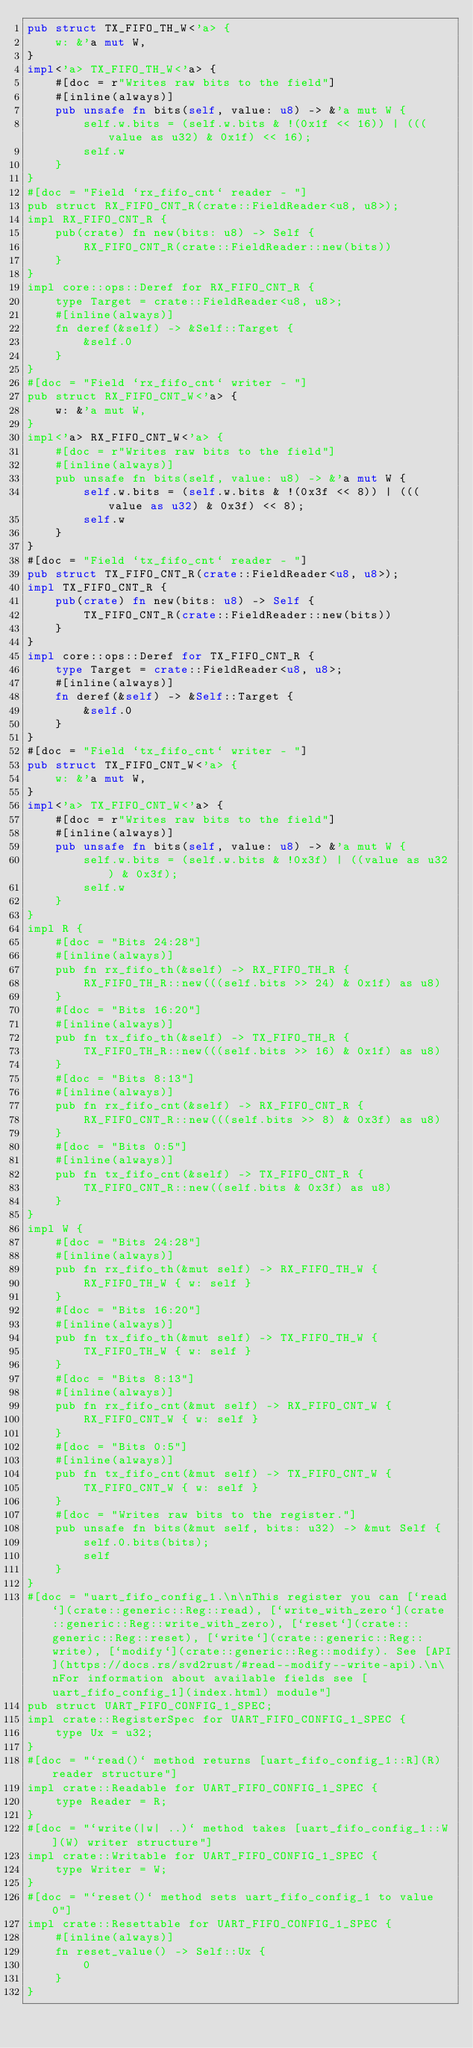Convert code to text. <code><loc_0><loc_0><loc_500><loc_500><_Rust_>pub struct TX_FIFO_TH_W<'a> {
    w: &'a mut W,
}
impl<'a> TX_FIFO_TH_W<'a> {
    #[doc = r"Writes raw bits to the field"]
    #[inline(always)]
    pub unsafe fn bits(self, value: u8) -> &'a mut W {
        self.w.bits = (self.w.bits & !(0x1f << 16)) | (((value as u32) & 0x1f) << 16);
        self.w
    }
}
#[doc = "Field `rx_fifo_cnt` reader - "]
pub struct RX_FIFO_CNT_R(crate::FieldReader<u8, u8>);
impl RX_FIFO_CNT_R {
    pub(crate) fn new(bits: u8) -> Self {
        RX_FIFO_CNT_R(crate::FieldReader::new(bits))
    }
}
impl core::ops::Deref for RX_FIFO_CNT_R {
    type Target = crate::FieldReader<u8, u8>;
    #[inline(always)]
    fn deref(&self) -> &Self::Target {
        &self.0
    }
}
#[doc = "Field `rx_fifo_cnt` writer - "]
pub struct RX_FIFO_CNT_W<'a> {
    w: &'a mut W,
}
impl<'a> RX_FIFO_CNT_W<'a> {
    #[doc = r"Writes raw bits to the field"]
    #[inline(always)]
    pub unsafe fn bits(self, value: u8) -> &'a mut W {
        self.w.bits = (self.w.bits & !(0x3f << 8)) | (((value as u32) & 0x3f) << 8);
        self.w
    }
}
#[doc = "Field `tx_fifo_cnt` reader - "]
pub struct TX_FIFO_CNT_R(crate::FieldReader<u8, u8>);
impl TX_FIFO_CNT_R {
    pub(crate) fn new(bits: u8) -> Self {
        TX_FIFO_CNT_R(crate::FieldReader::new(bits))
    }
}
impl core::ops::Deref for TX_FIFO_CNT_R {
    type Target = crate::FieldReader<u8, u8>;
    #[inline(always)]
    fn deref(&self) -> &Self::Target {
        &self.0
    }
}
#[doc = "Field `tx_fifo_cnt` writer - "]
pub struct TX_FIFO_CNT_W<'a> {
    w: &'a mut W,
}
impl<'a> TX_FIFO_CNT_W<'a> {
    #[doc = r"Writes raw bits to the field"]
    #[inline(always)]
    pub unsafe fn bits(self, value: u8) -> &'a mut W {
        self.w.bits = (self.w.bits & !0x3f) | ((value as u32) & 0x3f);
        self.w
    }
}
impl R {
    #[doc = "Bits 24:28"]
    #[inline(always)]
    pub fn rx_fifo_th(&self) -> RX_FIFO_TH_R {
        RX_FIFO_TH_R::new(((self.bits >> 24) & 0x1f) as u8)
    }
    #[doc = "Bits 16:20"]
    #[inline(always)]
    pub fn tx_fifo_th(&self) -> TX_FIFO_TH_R {
        TX_FIFO_TH_R::new(((self.bits >> 16) & 0x1f) as u8)
    }
    #[doc = "Bits 8:13"]
    #[inline(always)]
    pub fn rx_fifo_cnt(&self) -> RX_FIFO_CNT_R {
        RX_FIFO_CNT_R::new(((self.bits >> 8) & 0x3f) as u8)
    }
    #[doc = "Bits 0:5"]
    #[inline(always)]
    pub fn tx_fifo_cnt(&self) -> TX_FIFO_CNT_R {
        TX_FIFO_CNT_R::new((self.bits & 0x3f) as u8)
    }
}
impl W {
    #[doc = "Bits 24:28"]
    #[inline(always)]
    pub fn rx_fifo_th(&mut self) -> RX_FIFO_TH_W {
        RX_FIFO_TH_W { w: self }
    }
    #[doc = "Bits 16:20"]
    #[inline(always)]
    pub fn tx_fifo_th(&mut self) -> TX_FIFO_TH_W {
        TX_FIFO_TH_W { w: self }
    }
    #[doc = "Bits 8:13"]
    #[inline(always)]
    pub fn rx_fifo_cnt(&mut self) -> RX_FIFO_CNT_W {
        RX_FIFO_CNT_W { w: self }
    }
    #[doc = "Bits 0:5"]
    #[inline(always)]
    pub fn tx_fifo_cnt(&mut self) -> TX_FIFO_CNT_W {
        TX_FIFO_CNT_W { w: self }
    }
    #[doc = "Writes raw bits to the register."]
    pub unsafe fn bits(&mut self, bits: u32) -> &mut Self {
        self.0.bits(bits);
        self
    }
}
#[doc = "uart_fifo_config_1.\n\nThis register you can [`read`](crate::generic::Reg::read), [`write_with_zero`](crate::generic::Reg::write_with_zero), [`reset`](crate::generic::Reg::reset), [`write`](crate::generic::Reg::write), [`modify`](crate::generic::Reg::modify). See [API](https://docs.rs/svd2rust/#read--modify--write-api).\n\nFor information about available fields see [uart_fifo_config_1](index.html) module"]
pub struct UART_FIFO_CONFIG_1_SPEC;
impl crate::RegisterSpec for UART_FIFO_CONFIG_1_SPEC {
    type Ux = u32;
}
#[doc = "`read()` method returns [uart_fifo_config_1::R](R) reader structure"]
impl crate::Readable for UART_FIFO_CONFIG_1_SPEC {
    type Reader = R;
}
#[doc = "`write(|w| ..)` method takes [uart_fifo_config_1::W](W) writer structure"]
impl crate::Writable for UART_FIFO_CONFIG_1_SPEC {
    type Writer = W;
}
#[doc = "`reset()` method sets uart_fifo_config_1 to value 0"]
impl crate::Resettable for UART_FIFO_CONFIG_1_SPEC {
    #[inline(always)]
    fn reset_value() -> Self::Ux {
        0
    }
}
</code> 